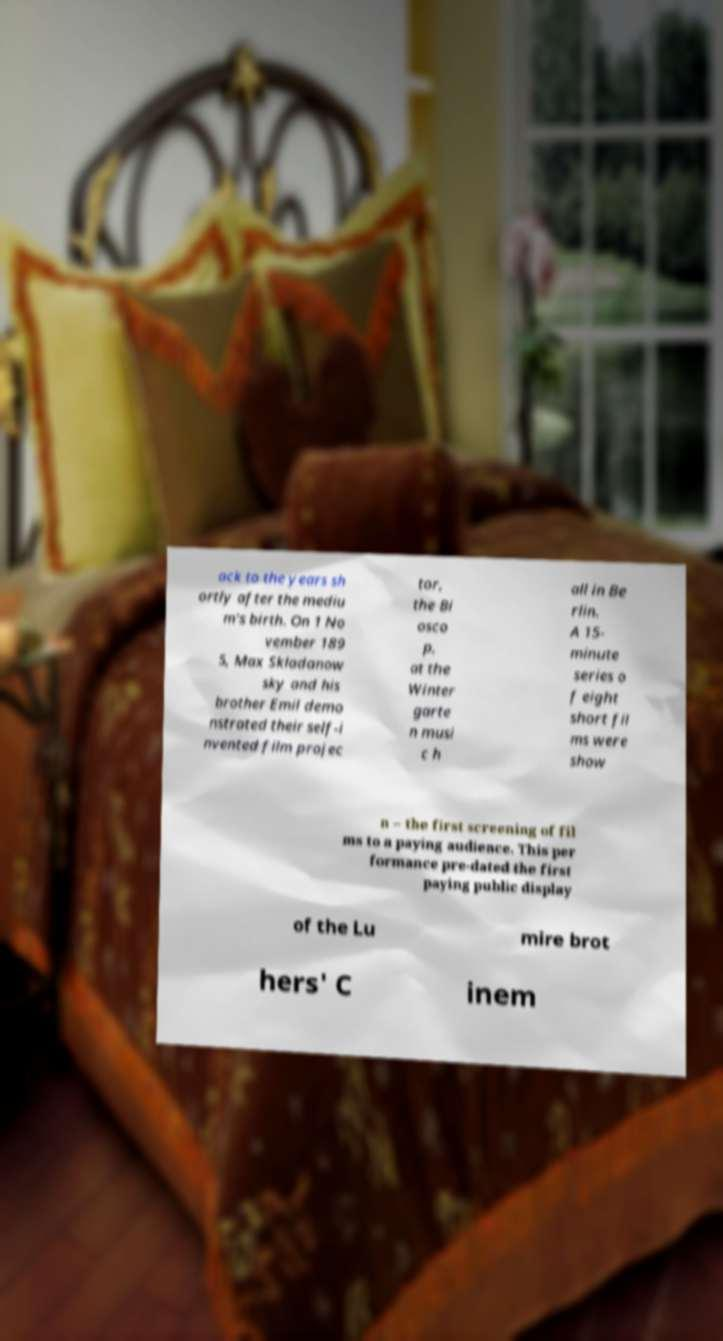Could you extract and type out the text from this image? ack to the years sh ortly after the mediu m's birth. On 1 No vember 189 5, Max Skladanow sky and his brother Emil demo nstrated their self-i nvented film projec tor, the Bi osco p, at the Winter garte n musi c h all in Be rlin. A 15- minute series o f eight short fil ms were show n – the first screening of fil ms to a paying audience. This per formance pre-dated the first paying public display of the Lu mire brot hers' C inem 